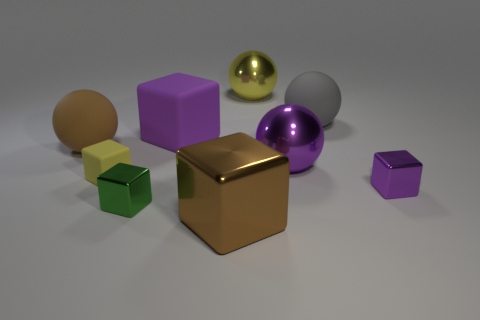Subtract all brown cubes. How many cubes are left? 4 Subtract all large purple cubes. How many cubes are left? 4 Subtract all cyan blocks. Subtract all brown cylinders. How many blocks are left? 5 Add 1 big cubes. How many objects exist? 10 Subtract all spheres. How many objects are left? 5 Subtract 1 yellow balls. How many objects are left? 8 Subtract all large yellow rubber cylinders. Subtract all gray spheres. How many objects are left? 8 Add 4 tiny yellow matte cubes. How many tiny yellow matte cubes are left? 5 Add 2 tiny gray balls. How many tiny gray balls exist? 2 